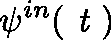Convert formula to latex. <formula><loc_0><loc_0><loc_500><loc_500>\psi ^ { i n } ( t )</formula> 